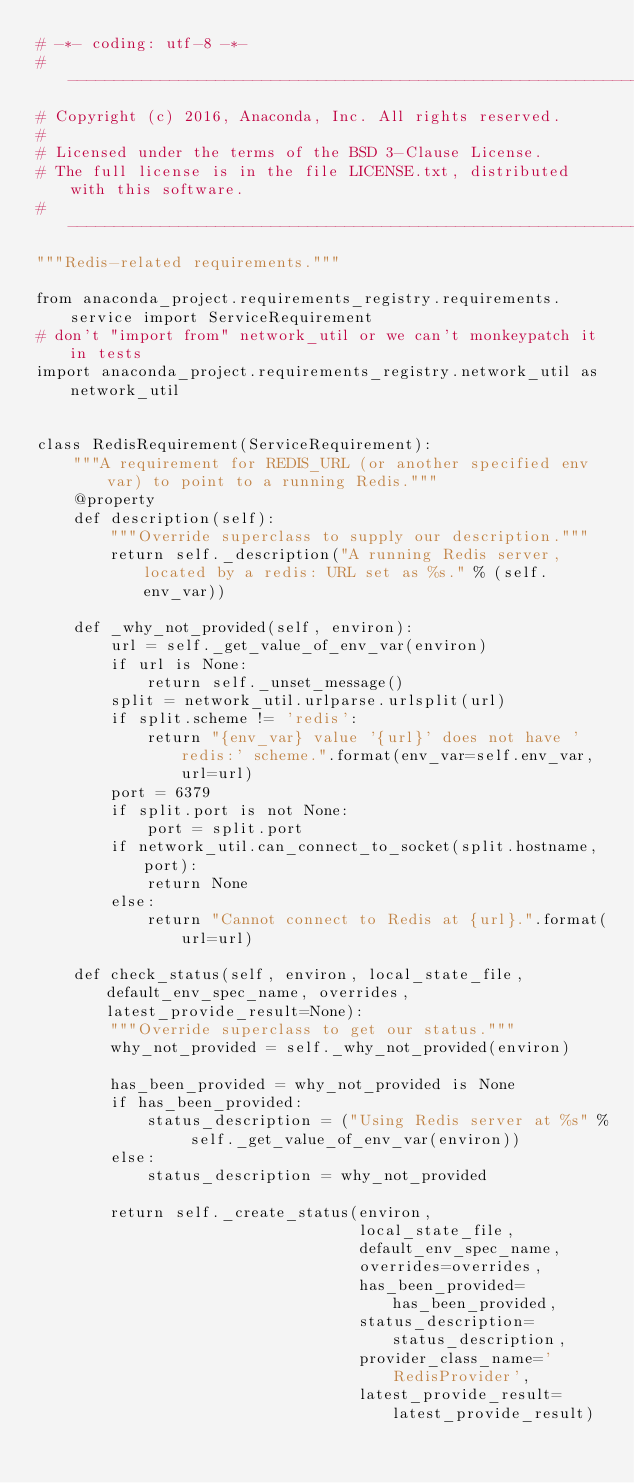Convert code to text. <code><loc_0><loc_0><loc_500><loc_500><_Python_># -*- coding: utf-8 -*-
# -----------------------------------------------------------------------------
# Copyright (c) 2016, Anaconda, Inc. All rights reserved.
#
# Licensed under the terms of the BSD 3-Clause License.
# The full license is in the file LICENSE.txt, distributed with this software.
# -----------------------------------------------------------------------------
"""Redis-related requirements."""

from anaconda_project.requirements_registry.requirements.service import ServiceRequirement
# don't "import from" network_util or we can't monkeypatch it in tests
import anaconda_project.requirements_registry.network_util as network_util


class RedisRequirement(ServiceRequirement):
    """A requirement for REDIS_URL (or another specified env var) to point to a running Redis."""
    @property
    def description(self):
        """Override superclass to supply our description."""
        return self._description("A running Redis server, located by a redis: URL set as %s." % (self.env_var))

    def _why_not_provided(self, environ):
        url = self._get_value_of_env_var(environ)
        if url is None:
            return self._unset_message()
        split = network_util.urlparse.urlsplit(url)
        if split.scheme != 'redis':
            return "{env_var} value '{url}' does not have 'redis:' scheme.".format(env_var=self.env_var, url=url)
        port = 6379
        if split.port is not None:
            port = split.port
        if network_util.can_connect_to_socket(split.hostname, port):
            return None
        else:
            return "Cannot connect to Redis at {url}.".format(url=url)

    def check_status(self, environ, local_state_file, default_env_spec_name, overrides, latest_provide_result=None):
        """Override superclass to get our status."""
        why_not_provided = self._why_not_provided(environ)

        has_been_provided = why_not_provided is None
        if has_been_provided:
            status_description = ("Using Redis server at %s" % self._get_value_of_env_var(environ))
        else:
            status_description = why_not_provided

        return self._create_status(environ,
                                   local_state_file,
                                   default_env_spec_name,
                                   overrides=overrides,
                                   has_been_provided=has_been_provided,
                                   status_description=status_description,
                                   provider_class_name='RedisProvider',
                                   latest_provide_result=latest_provide_result)
</code> 